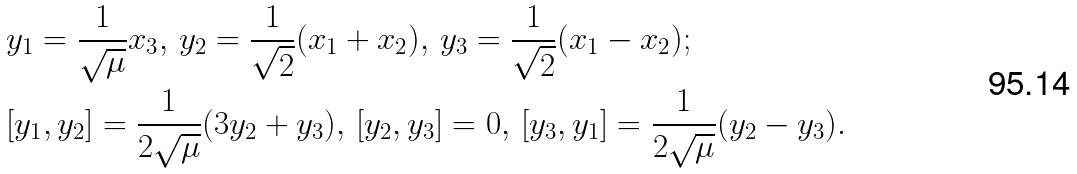<formula> <loc_0><loc_0><loc_500><loc_500>& y _ { 1 } = \frac { 1 } { \sqrt { \mu } } x _ { 3 } , \, y _ { 2 } = \frac { 1 } { \sqrt { 2 } } ( x _ { 1 } + x _ { 2 } ) , \, y _ { 3 } = \frac { 1 } { \sqrt { 2 } } ( x _ { 1 } - x _ { 2 } ) ; \\ & [ y _ { 1 } , y _ { 2 } ] = \frac { 1 } { 2 \sqrt { \mu } } ( 3 y _ { 2 } + y _ { 3 } ) , \, [ y _ { 2 } , y _ { 3 } ] = 0 , \, [ y _ { 3 } , y _ { 1 } ] = \frac { 1 } { 2 \sqrt { \mu } } ( y _ { 2 } - y _ { 3 } ) .</formula> 